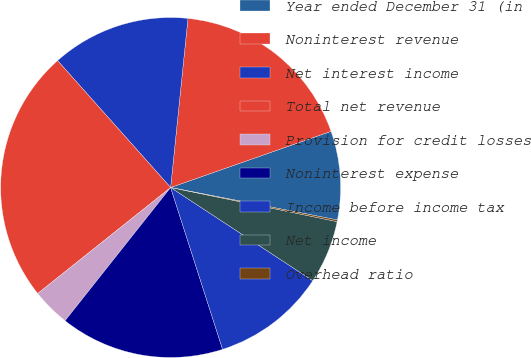<chart> <loc_0><loc_0><loc_500><loc_500><pie_chart><fcel>Year ended December 31 (in<fcel>Noninterest revenue<fcel>Net interest income<fcel>Total net revenue<fcel>Provision for credit losses<fcel>Noninterest expense<fcel>Income before income tax<fcel>Net income<fcel>Overhead ratio<nl><fcel>8.42%<fcel>18.01%<fcel>13.21%<fcel>24.13%<fcel>3.62%<fcel>15.61%<fcel>10.82%<fcel>6.02%<fcel>0.16%<nl></chart> 